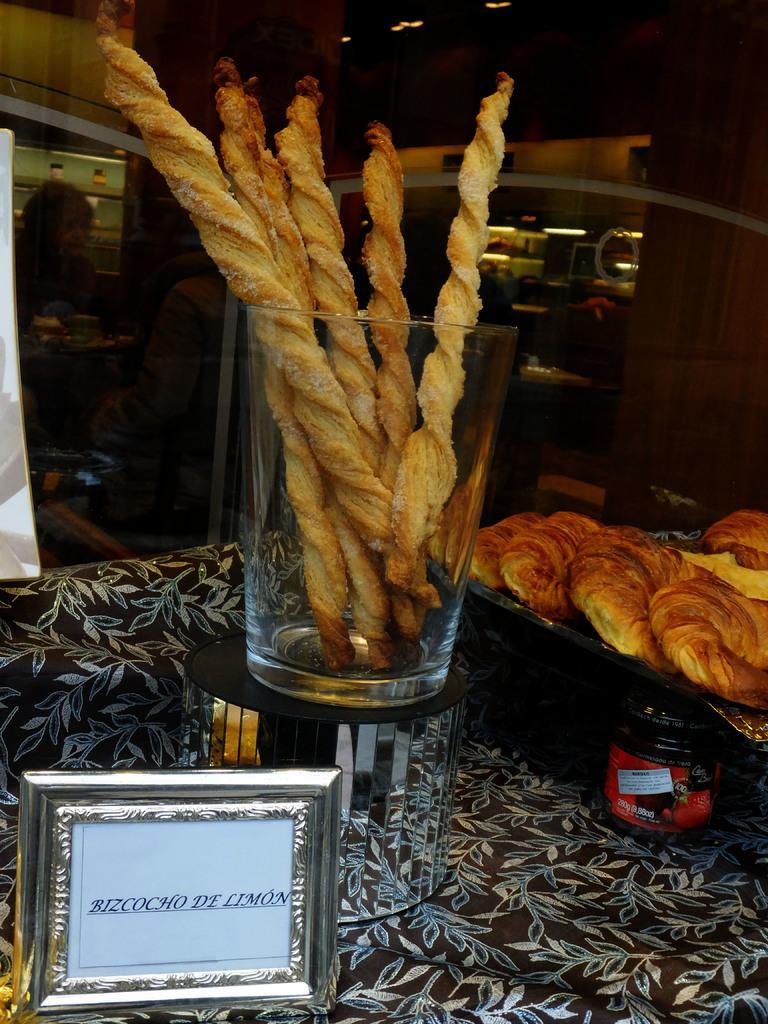How would you summarize this image in a sentence or two? This image is taken indoors. At the bottom of the image there is a table with a table cloth, a tray with puffs, a glass with churros and a board with text on it. In the background there is a wall and there are a few things. At the top of the image there is a ceiling. 